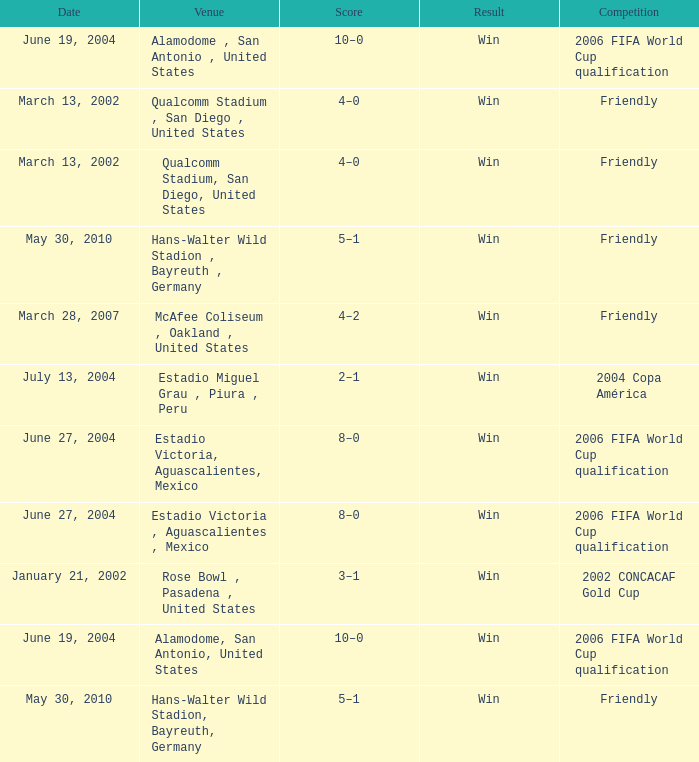What is the significance or outcome related to january 21, 2002? Win. 